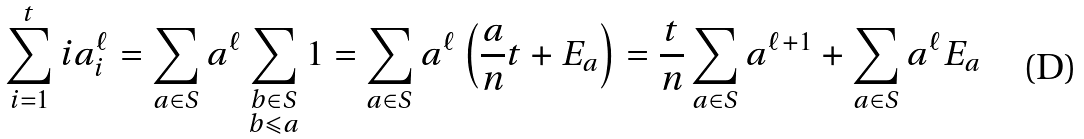<formula> <loc_0><loc_0><loc_500><loc_500>\sum _ { i = 1 } ^ { t } i a _ { i } ^ { \ell } = \sum _ { a \in S } a ^ { \ell } \sum _ { \substack { b \in S \\ b \leqslant a } } 1 = \sum _ { a \in S } a ^ { \ell } \left ( \frac { a } { n } t + E _ { a } \right ) = \frac { t } { n } \sum _ { a \in S } a ^ { \ell + 1 } + \sum _ { a \in S } a ^ { \ell } E _ { a }</formula> 